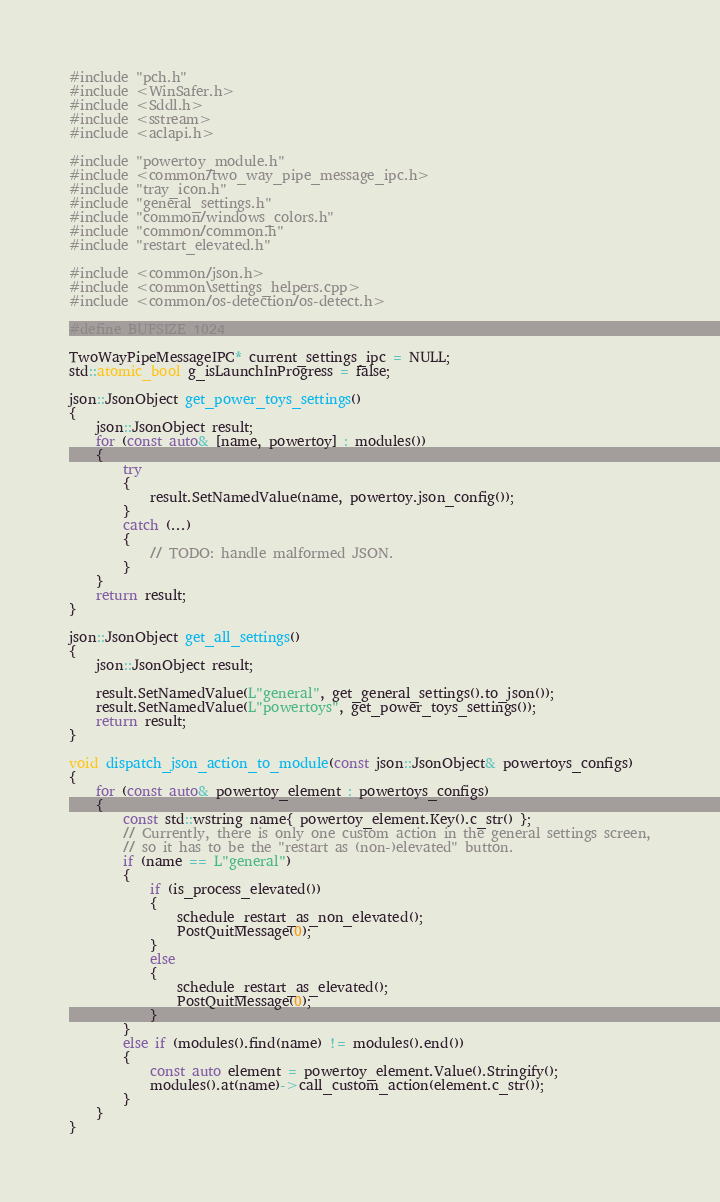<code> <loc_0><loc_0><loc_500><loc_500><_C++_>#include "pch.h"
#include <WinSafer.h>
#include <Sddl.h>
#include <sstream>
#include <aclapi.h>

#include "powertoy_module.h"
#include <common/two_way_pipe_message_ipc.h>
#include "tray_icon.h"
#include "general_settings.h"
#include "common/windows_colors.h"
#include "common/common.h"
#include "restart_elevated.h"

#include <common/json.h>
#include <common\settings_helpers.cpp>
#include <common/os-detection/os-detect.h>

#define BUFSIZE 1024

TwoWayPipeMessageIPC* current_settings_ipc = NULL;
std::atomic_bool g_isLaunchInProgress = false;

json::JsonObject get_power_toys_settings()
{
    json::JsonObject result;
    for (const auto& [name, powertoy] : modules())
    {
        try
        {
            result.SetNamedValue(name, powertoy.json_config());
        }
        catch (...)
        {
            // TODO: handle malformed JSON.
        }
    }
    return result;
}

json::JsonObject get_all_settings()
{
    json::JsonObject result;

    result.SetNamedValue(L"general", get_general_settings().to_json());
    result.SetNamedValue(L"powertoys", get_power_toys_settings());
    return result;
}

void dispatch_json_action_to_module(const json::JsonObject& powertoys_configs)
{
    for (const auto& powertoy_element : powertoys_configs)
    {
        const std::wstring name{ powertoy_element.Key().c_str() };
        // Currently, there is only one custom action in the general settings screen,
        // so it has to be the "restart as (non-)elevated" button.
        if (name == L"general")
        {
            if (is_process_elevated())
            {
                schedule_restart_as_non_elevated();
                PostQuitMessage(0);
            }
            else
            {
                schedule_restart_as_elevated();
                PostQuitMessage(0);
            }
        }
        else if (modules().find(name) != modules().end())
        {
            const auto element = powertoy_element.Value().Stringify();
            modules().at(name)->call_custom_action(element.c_str());
        }
    }
}
</code> 